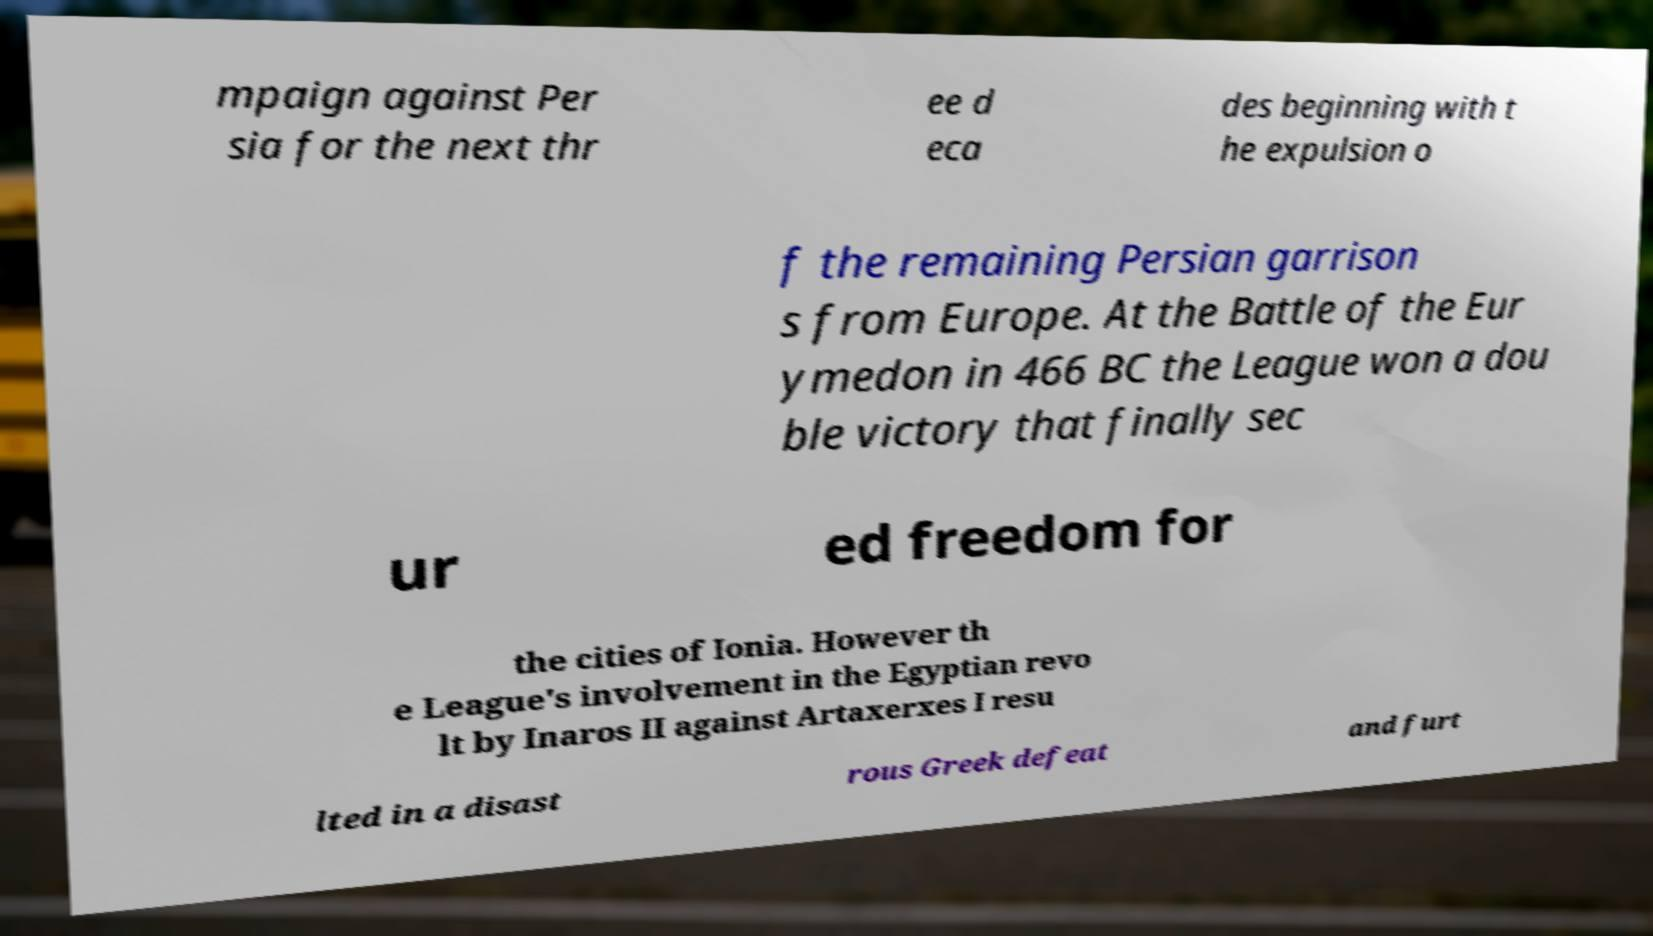Please identify and transcribe the text found in this image. mpaign against Per sia for the next thr ee d eca des beginning with t he expulsion o f the remaining Persian garrison s from Europe. At the Battle of the Eur ymedon in 466 BC the League won a dou ble victory that finally sec ur ed freedom for the cities of Ionia. However th e League's involvement in the Egyptian revo lt by Inaros II against Artaxerxes I resu lted in a disast rous Greek defeat and furt 